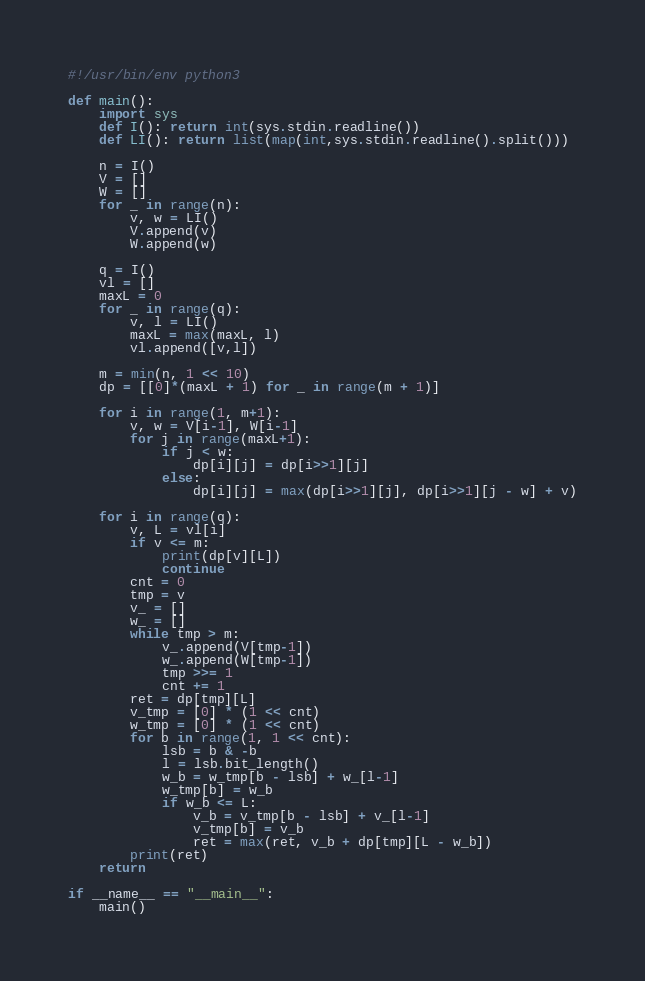<code> <loc_0><loc_0><loc_500><loc_500><_Python_>#!/usr/bin/env python3

def main():
    import sys
    def I(): return int(sys.stdin.readline())
    def LI(): return list(map(int,sys.stdin.readline().split()))

    n = I()
    V = []
    W = []
    for _ in range(n):
        v, w = LI()
        V.append(v)
        W.append(w)
    
    q = I()
    vl = []
    maxL = 0
    for _ in range(q):
        v, l = LI()
        maxL = max(maxL, l)
        vl.append([v,l])
    
    m = min(n, 1 << 10)
    dp = [[0]*(maxL + 1) for _ in range(m + 1)]
    
    for i in range(1, m+1):
        v, w = V[i-1], W[i-1]
        for j in range(maxL+1):
            if j < w:
                dp[i][j] = dp[i>>1][j]
            else:
                dp[i][j] = max(dp[i>>1][j], dp[i>>1][j - w] + v)
    
    for i in range(q):
        v, L = vl[i]
        if v <= m:
            print(dp[v][L])
            continue
        cnt = 0
        tmp = v
        v_ = []
        w_ = []
        while tmp > m:
            v_.append(V[tmp-1])
            w_.append(W[tmp-1])
            tmp >>= 1
            cnt += 1
        ret = dp[tmp][L]
        v_tmp = [0] * (1 << cnt)
        w_tmp = [0] * (1 << cnt)
        for b in range(1, 1 << cnt):
            lsb = b & -b
            l = lsb.bit_length()
            w_b = w_tmp[b - lsb] + w_[l-1]
            w_tmp[b] = w_b
            if w_b <= L:
                v_b = v_tmp[b - lsb] + v_[l-1]
                v_tmp[b] = v_b
                ret = max(ret, v_b + dp[tmp][L - w_b])
        print(ret)
    return

if __name__ == "__main__":
    main()</code> 